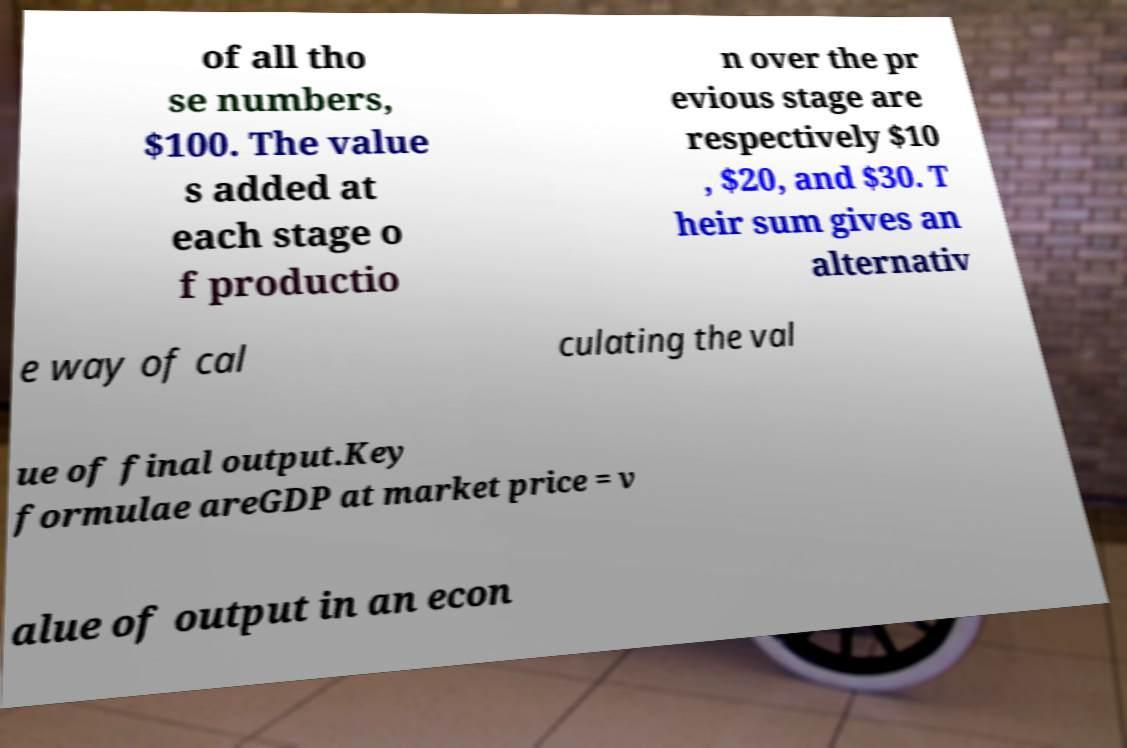Please read and relay the text visible in this image. What does it say? of all tho se numbers, $100. The value s added at each stage o f productio n over the pr evious stage are respectively $10 , $20, and $30. T heir sum gives an alternativ e way of cal culating the val ue of final output.Key formulae areGDP at market price = v alue of output in an econ 